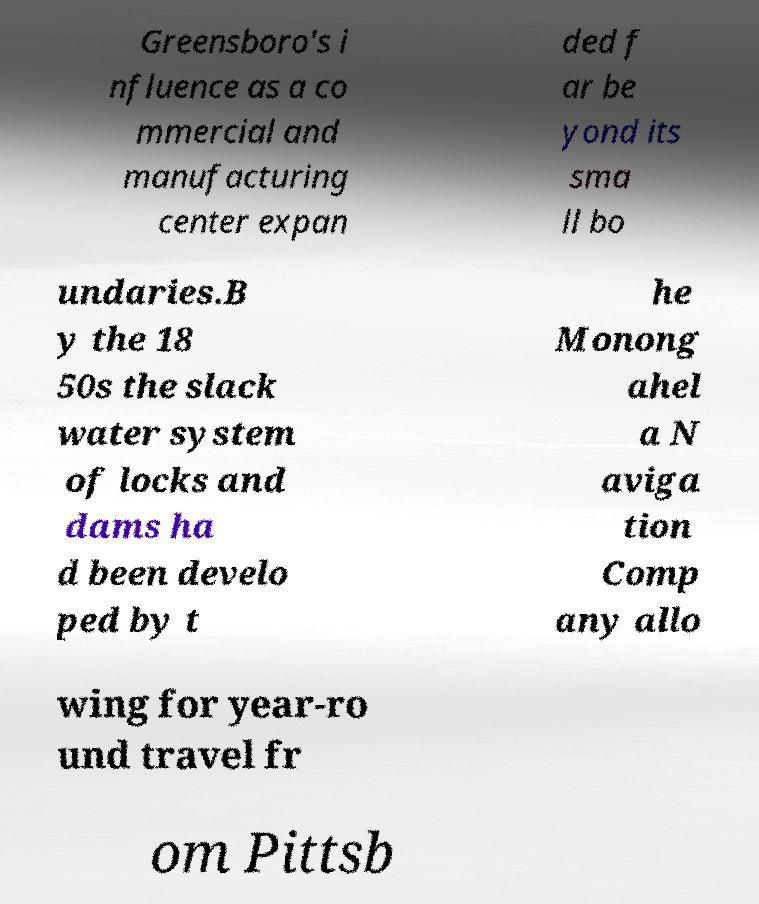Please identify and transcribe the text found in this image. Greensboro's i nfluence as a co mmercial and manufacturing center expan ded f ar be yond its sma ll bo undaries.B y the 18 50s the slack water system of locks and dams ha d been develo ped by t he Monong ahel a N aviga tion Comp any allo wing for year-ro und travel fr om Pittsb 